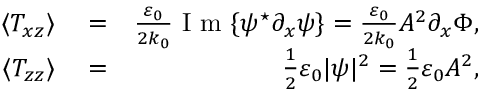Convert formula to latex. <formula><loc_0><loc_0><loc_500><loc_500>\begin{array} { r l r } { \langle T _ { x z } \rangle } & = } & { \frac { \varepsilon _ { 0 } } { 2 k _ { 0 } } I m \{ \psi ^ { ^ { * } } \partial _ { x } \psi \} = \frac { \varepsilon _ { 0 } } { 2 k _ { 0 } } A ^ { 2 } \partial _ { x } \Phi , } \\ { \langle T _ { z z } \rangle } & = } & { \frac { 1 } { 2 } \varepsilon _ { 0 } | \psi | ^ { 2 } = \frac { 1 } { 2 } \varepsilon _ { 0 } A ^ { 2 } , } \end{array}</formula> 